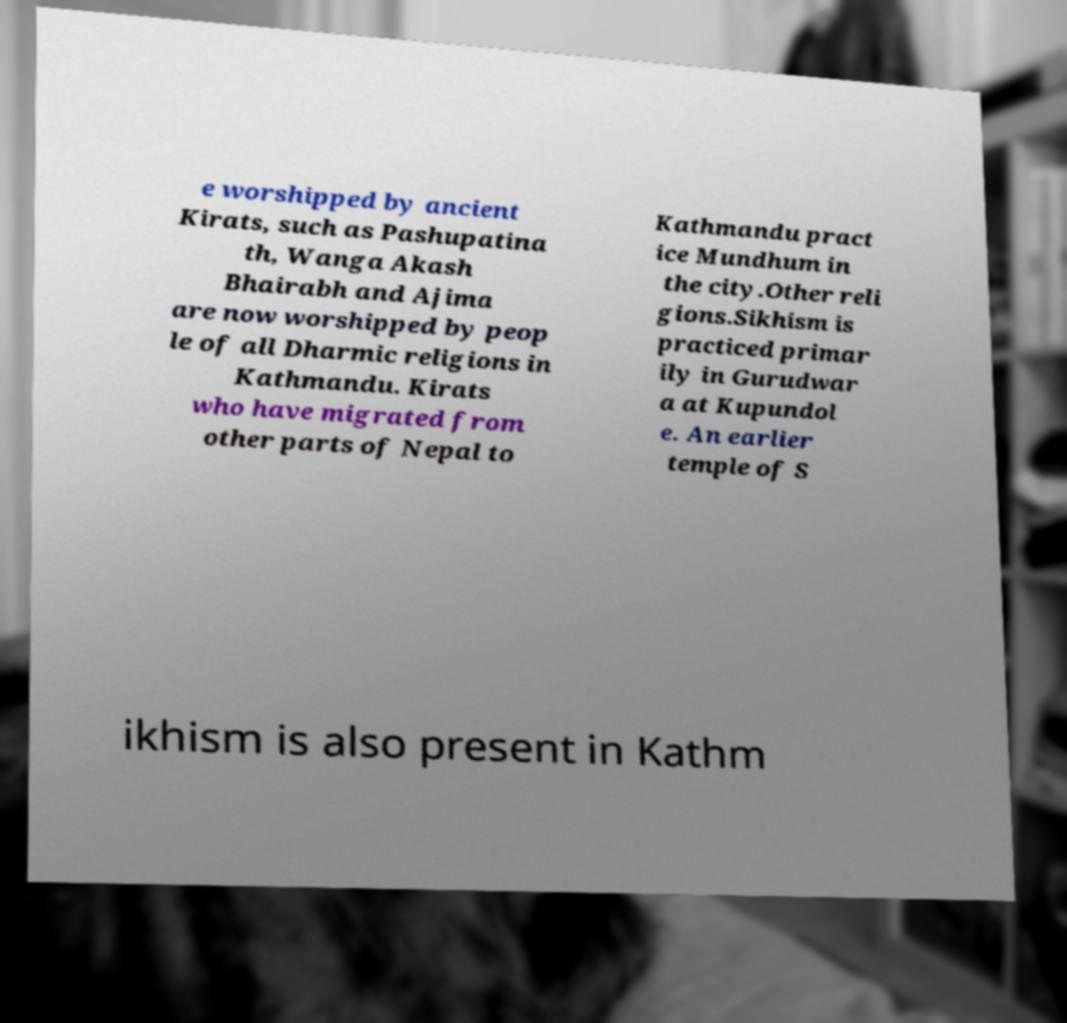There's text embedded in this image that I need extracted. Can you transcribe it verbatim? e worshipped by ancient Kirats, such as Pashupatina th, Wanga Akash Bhairabh and Ajima are now worshipped by peop le of all Dharmic religions in Kathmandu. Kirats who have migrated from other parts of Nepal to Kathmandu pract ice Mundhum in the city.Other reli gions.Sikhism is practiced primar ily in Gurudwar a at Kupundol e. An earlier temple of S ikhism is also present in Kathm 